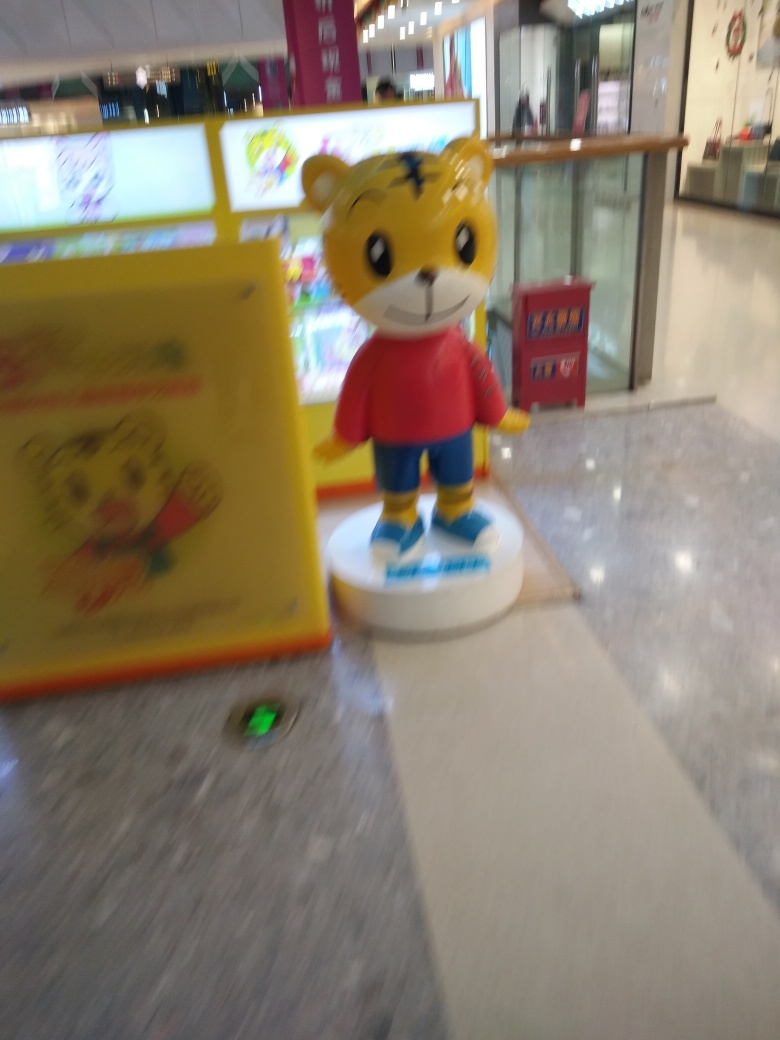Are the texture details of the photographed subject lost? Yes, the texture details are somewhat lost due to the motion blur and out-of-focus capture of the image. This results in a softness that obscures finer details of the subject, such as the fur texture and facial features. 